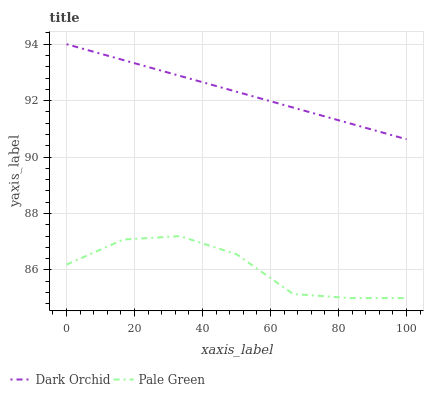Does Dark Orchid have the minimum area under the curve?
Answer yes or no. No. Is Dark Orchid the roughest?
Answer yes or no. No. Does Dark Orchid have the lowest value?
Answer yes or no. No. Is Pale Green less than Dark Orchid?
Answer yes or no. Yes. Is Dark Orchid greater than Pale Green?
Answer yes or no. Yes. Does Pale Green intersect Dark Orchid?
Answer yes or no. No. 